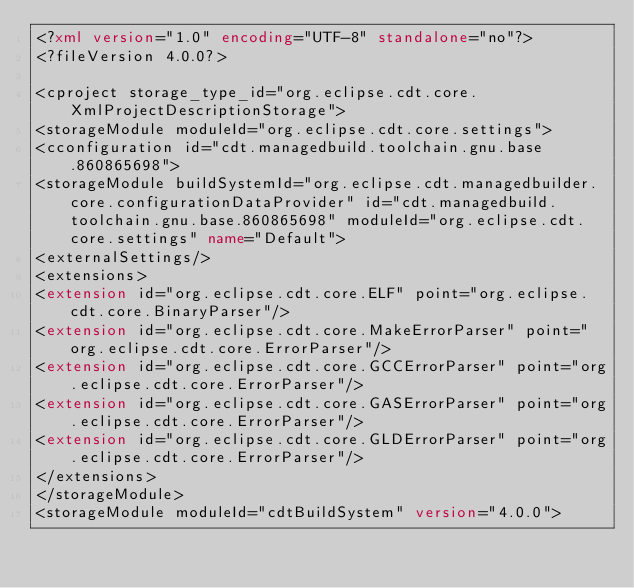<code> <loc_0><loc_0><loc_500><loc_500><_XML_><?xml version="1.0" encoding="UTF-8" standalone="no"?>
<?fileVersion 4.0.0?>

<cproject storage_type_id="org.eclipse.cdt.core.XmlProjectDescriptionStorage">
<storageModule moduleId="org.eclipse.cdt.core.settings">
<cconfiguration id="cdt.managedbuild.toolchain.gnu.base.860865698">
<storageModule buildSystemId="org.eclipse.cdt.managedbuilder.core.configurationDataProvider" id="cdt.managedbuild.toolchain.gnu.base.860865698" moduleId="org.eclipse.cdt.core.settings" name="Default">
<externalSettings/>
<extensions>
<extension id="org.eclipse.cdt.core.ELF" point="org.eclipse.cdt.core.BinaryParser"/>
<extension id="org.eclipse.cdt.core.MakeErrorParser" point="org.eclipse.cdt.core.ErrorParser"/>
<extension id="org.eclipse.cdt.core.GCCErrorParser" point="org.eclipse.cdt.core.ErrorParser"/>
<extension id="org.eclipse.cdt.core.GASErrorParser" point="org.eclipse.cdt.core.ErrorParser"/>
<extension id="org.eclipse.cdt.core.GLDErrorParser" point="org.eclipse.cdt.core.ErrorParser"/>
</extensions>
</storageModule>
<storageModule moduleId="cdtBuildSystem" version="4.0.0"></code> 